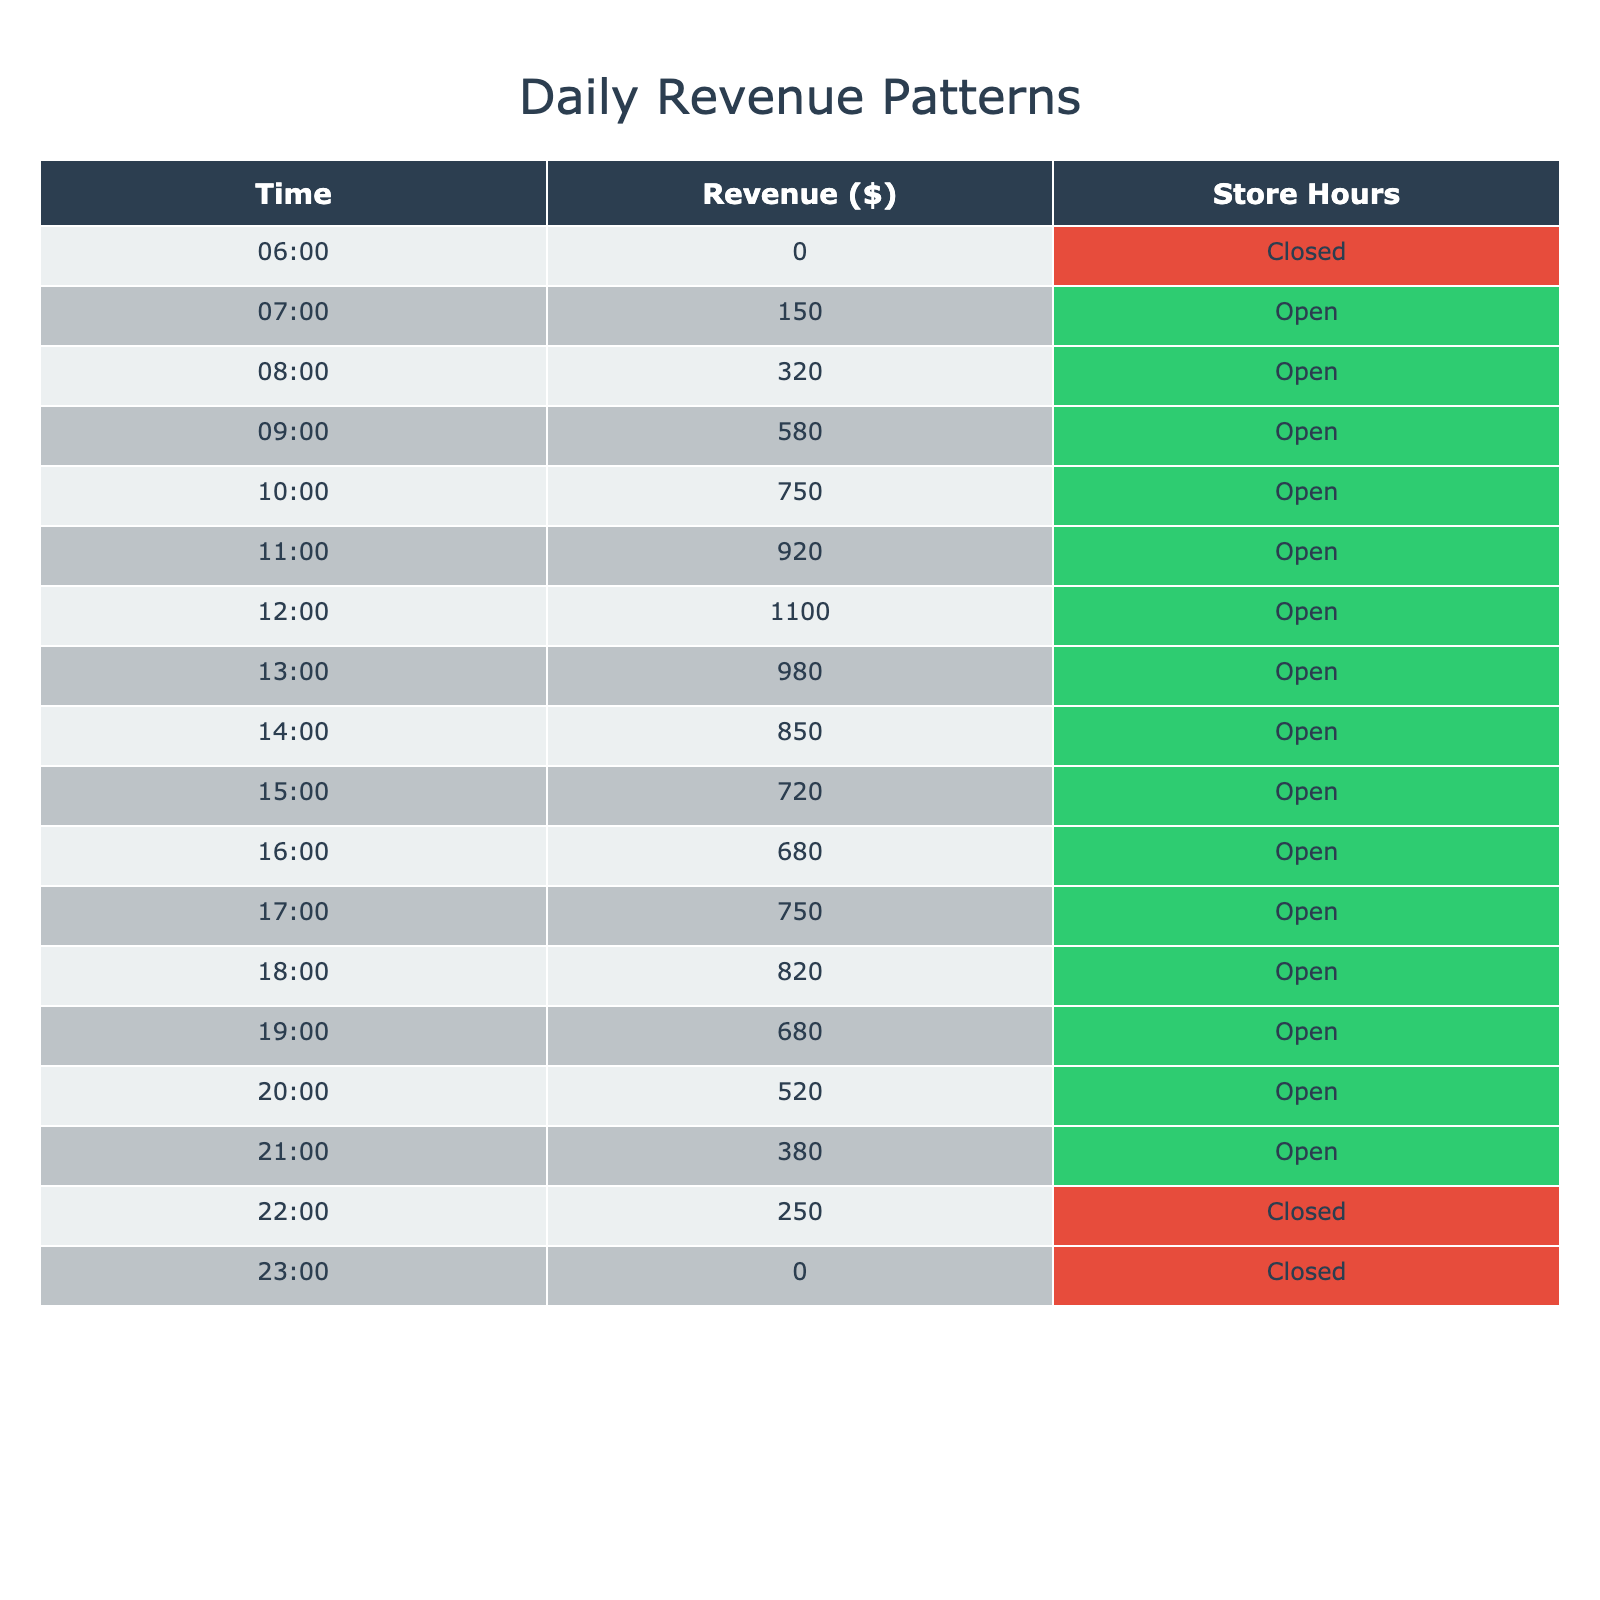What is the highest revenue recorded during store hours? According to the table, the highest revenue is listed at 1100 dollars at 12:00 PM, while the store is open at that time.
Answer: 1100 What time did the store close for the day? The table indicates that the store closed at 11:00 PM, having recorded no revenue during that time.
Answer: 11:00 PM What is the total revenue from 6:00 AM to 10:00 AM? To find this, we need to sum the revenue from 6:00 AM to 10:00 AM: 0 (6 AM) + 150 (7 AM) + 320 (8 AM) + 580 (9 AM) + 750 (10 AM) = 1800 dollars.
Answer: 1800 Did the store generate any revenue during the hours it was closed? Referring to the table, it shows that the store generated zero revenue during the times it was closed, specifically at 6:00 AM, 10:00 PM, and 11:00 PM.
Answer: No What was the revenue pattern in the first three hours after opening? The revenues in the first three hours after opening (from 7 AM to 9 AM) were 150, 320, and 580 dollars respectively. This shows a steady increase in revenue, totaling 1050 dollars.
Answer: Increasing What is the average revenue between 1:00 PM and 6:00 PM? To calculate the average revenue during this period, we consider the revenues from 1 PM to 6 PM: 980 (1 PM), 850 (2 PM), 720 (3 PM), 680 (4 PM), 750 (5 PM), and 820 (6 PM). The total is 4800 dollars, and there are 6 data points, so the average is 4800/6 = 800 dollars.
Answer: 800 What was the revenue drop from 12:00 PM to 1:00 PM? To find the revenue drop from 12:00 PM to 1:00 PM, we subtract the revenue at 1 PM (980 dollars) from the revenue at 12 PM (1100 dollars): 1100 - 980 = 120 dollars.
Answer: 120 How many hours did the store remain open in total? By counting the time slots listed in the table where the store hours are marked as "Open," it is clear that the store was open from 7 AM to 10 PM, totaling 15 hours.
Answer: 15 hours What is the revenue pattern for the evening hours (6 PM to 10 PM)? The revenues from 6 PM to 10 PM were 820 (6 PM), 680 (7 PM), 520 (8 PM), and 380 (9 PM). This indicates a decreasing trend in revenue during the evening hours, leading to a total of 2400 dollars over the four hours.
Answer: Decreasing 